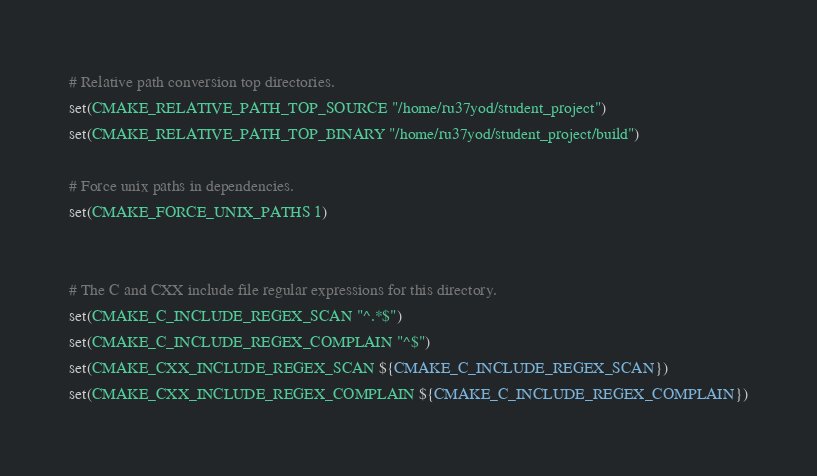Convert code to text. <code><loc_0><loc_0><loc_500><loc_500><_CMake_># Relative path conversion top directories.
set(CMAKE_RELATIVE_PATH_TOP_SOURCE "/home/ru37yod/student_project")
set(CMAKE_RELATIVE_PATH_TOP_BINARY "/home/ru37yod/student_project/build")

# Force unix paths in dependencies.
set(CMAKE_FORCE_UNIX_PATHS 1)


# The C and CXX include file regular expressions for this directory.
set(CMAKE_C_INCLUDE_REGEX_SCAN "^.*$")
set(CMAKE_C_INCLUDE_REGEX_COMPLAIN "^$")
set(CMAKE_CXX_INCLUDE_REGEX_SCAN ${CMAKE_C_INCLUDE_REGEX_SCAN})
set(CMAKE_CXX_INCLUDE_REGEX_COMPLAIN ${CMAKE_C_INCLUDE_REGEX_COMPLAIN})
</code> 